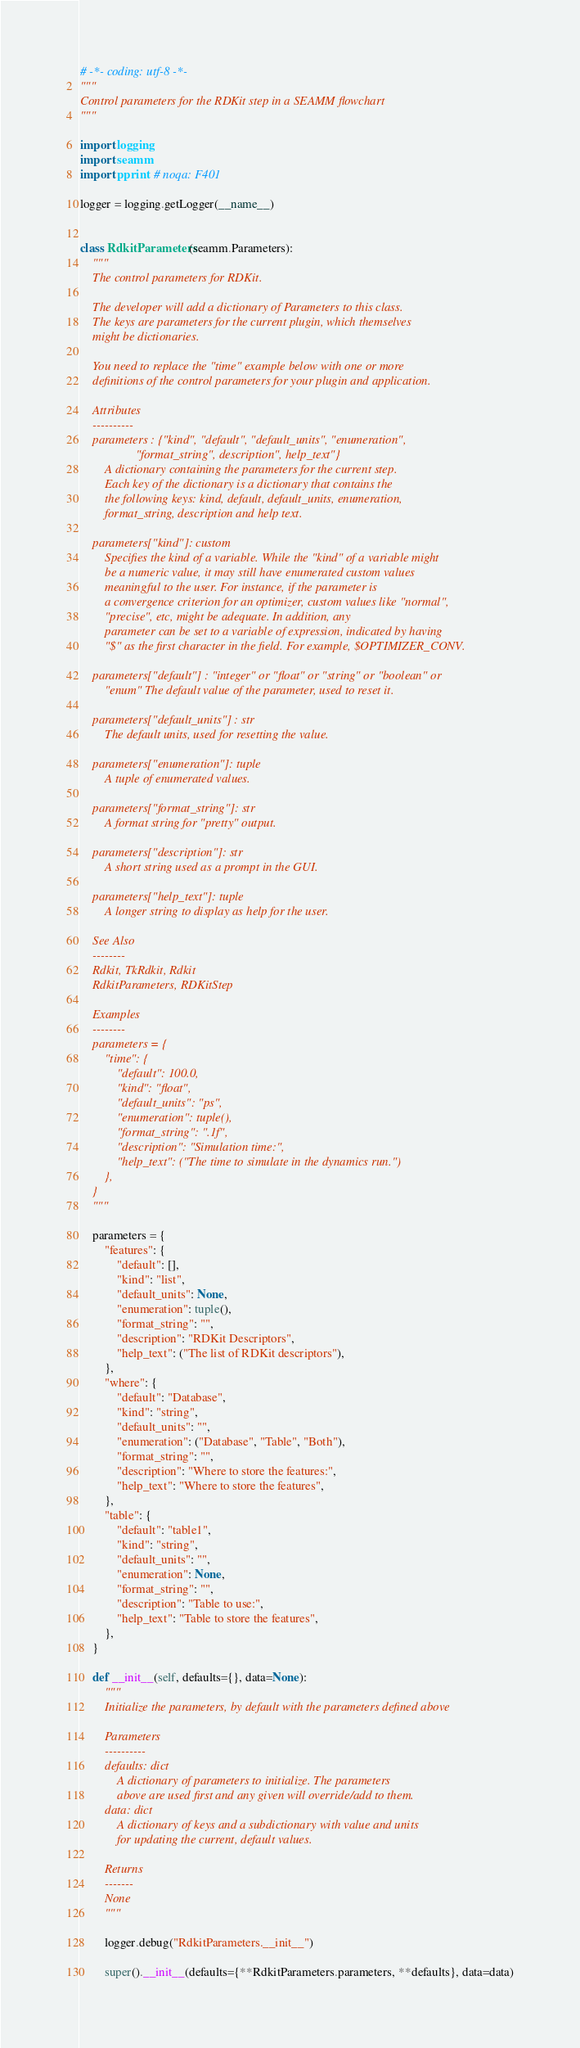Convert code to text. <code><loc_0><loc_0><loc_500><loc_500><_Python_># -*- coding: utf-8 -*-
"""
Control parameters for the RDKit step in a SEAMM flowchart
"""

import logging
import seamm
import pprint  # noqa: F401

logger = logging.getLogger(__name__)


class RdkitParameters(seamm.Parameters):
    """
    The control parameters for RDKit.

    The developer will add a dictionary of Parameters to this class.
    The keys are parameters for the current plugin, which themselves
    might be dictionaries.

    You need to replace the "time" example below with one or more
    definitions of the control parameters for your plugin and application.

    Attributes
    ----------
    parameters : {"kind", "default", "default_units", "enumeration",
                  "format_string", description", help_text"}
        A dictionary containing the parameters for the current step.
        Each key of the dictionary is a dictionary that contains the
        the following keys: kind, default, default_units, enumeration,
        format_string, description and help text.

    parameters["kind"]: custom
        Specifies the kind of a variable. While the "kind" of a variable might
        be a numeric value, it may still have enumerated custom values
        meaningful to the user. For instance, if the parameter is
        a convergence criterion for an optimizer, custom values like "normal",
        "precise", etc, might be adequate. In addition, any
        parameter can be set to a variable of expression, indicated by having
        "$" as the first character in the field. For example, $OPTIMIZER_CONV.

    parameters["default"] : "integer" or "float" or "string" or "boolean" or
        "enum" The default value of the parameter, used to reset it.

    parameters["default_units"] : str
        The default units, used for resetting the value.

    parameters["enumeration"]: tuple
        A tuple of enumerated values.

    parameters["format_string"]: str
        A format string for "pretty" output.

    parameters["description"]: str
        A short string used as a prompt in the GUI.

    parameters["help_text"]: tuple
        A longer string to display as help for the user.

    See Also
    --------
    Rdkit, TkRdkit, Rdkit
    RdkitParameters, RDKitStep

    Examples
    --------
    parameters = {
        "time": {
            "default": 100.0,
            "kind": "float",
            "default_units": "ps",
            "enumeration": tuple(),
            "format_string": ".1f",
            "description": "Simulation time:",
            "help_text": ("The time to simulate in the dynamics run.")
        },
    }
    """

    parameters = {
        "features": {
            "default": [],
            "kind": "list",
            "default_units": None,
            "enumeration": tuple(),
            "format_string": "",
            "description": "RDKit Descriptors",
            "help_text": ("The list of RDKit descriptors"),
        },
        "where": {
            "default": "Database",
            "kind": "string",
            "default_units": "",
            "enumeration": ("Database", "Table", "Both"),
            "format_string": "",
            "description": "Where to store the features:",
            "help_text": "Where to store the features",
        },
        "table": {
            "default": "table1",
            "kind": "string",
            "default_units": "",
            "enumeration": None,
            "format_string": "",
            "description": "Table to use:",
            "help_text": "Table to store the features",
        },
    }

    def __init__(self, defaults={}, data=None):
        """
        Initialize the parameters, by default with the parameters defined above

        Parameters
        ----------
        defaults: dict
            A dictionary of parameters to initialize. The parameters
            above are used first and any given will override/add to them.
        data: dict
            A dictionary of keys and a subdictionary with value and units
            for updating the current, default values.

        Returns
        -------
        None
        """

        logger.debug("RdkitParameters.__init__")

        super().__init__(defaults={**RdkitParameters.parameters, **defaults}, data=data)
</code> 